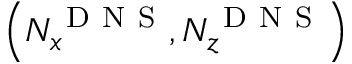<formula> <loc_0><loc_0><loc_500><loc_500>\left ( N _ { x } ^ { D N S } , N _ { z } ^ { D N S } \right )</formula> 